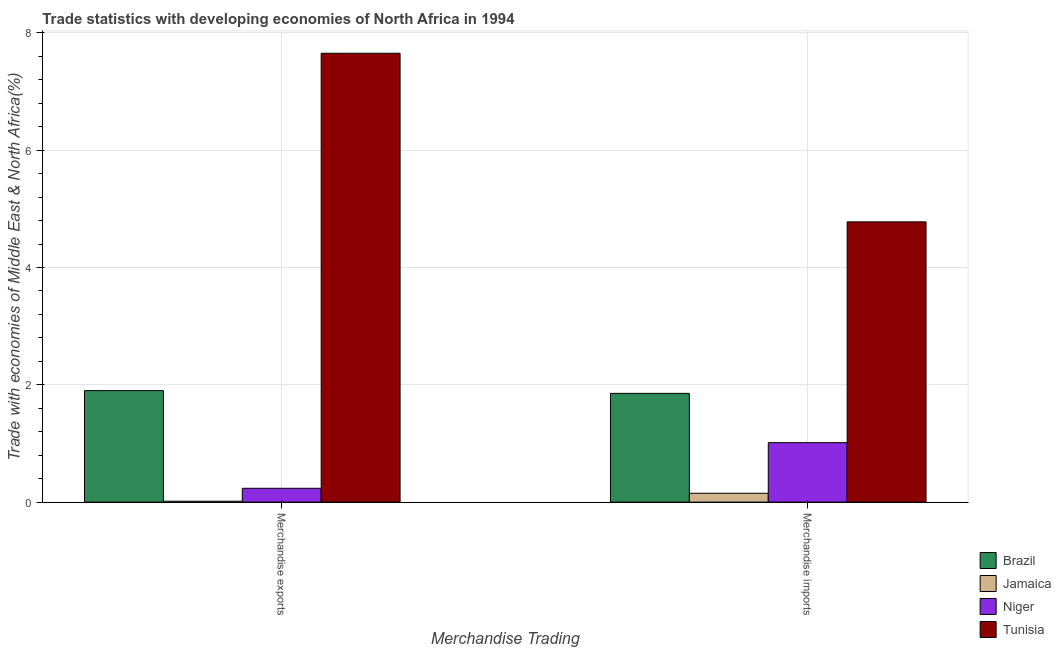How many different coloured bars are there?
Keep it short and to the point. 4. Are the number of bars per tick equal to the number of legend labels?
Offer a very short reply. Yes. How many bars are there on the 2nd tick from the left?
Provide a succinct answer. 4. What is the label of the 1st group of bars from the left?
Your answer should be very brief. Merchandise exports. What is the merchandise exports in Brazil?
Ensure brevity in your answer.  1.9. Across all countries, what is the maximum merchandise imports?
Give a very brief answer. 4.78. Across all countries, what is the minimum merchandise imports?
Your response must be concise. 0.15. In which country was the merchandise exports maximum?
Your response must be concise. Tunisia. In which country was the merchandise imports minimum?
Your answer should be compact. Jamaica. What is the total merchandise imports in the graph?
Your response must be concise. 7.8. What is the difference between the merchandise exports in Jamaica and that in Niger?
Make the answer very short. -0.22. What is the difference between the merchandise exports in Niger and the merchandise imports in Tunisia?
Give a very brief answer. -4.54. What is the average merchandise imports per country?
Give a very brief answer. 1.95. What is the difference between the merchandise imports and merchandise exports in Jamaica?
Make the answer very short. 0.14. In how many countries, is the merchandise exports greater than 5.6 %?
Keep it short and to the point. 1. What is the ratio of the merchandise exports in Tunisia to that in Jamaica?
Your answer should be compact. 501.51. Is the merchandise exports in Niger less than that in Brazil?
Your response must be concise. Yes. In how many countries, is the merchandise imports greater than the average merchandise imports taken over all countries?
Your answer should be compact. 1. What does the 3rd bar from the right in Merchandise imports represents?
Make the answer very short. Jamaica. How many countries are there in the graph?
Give a very brief answer. 4. What is the difference between two consecutive major ticks on the Y-axis?
Provide a short and direct response. 2. Are the values on the major ticks of Y-axis written in scientific E-notation?
Your response must be concise. No. Does the graph contain any zero values?
Offer a very short reply. No. Does the graph contain grids?
Give a very brief answer. Yes. How many legend labels are there?
Your answer should be compact. 4. What is the title of the graph?
Your response must be concise. Trade statistics with developing economies of North Africa in 1994. What is the label or title of the X-axis?
Keep it short and to the point. Merchandise Trading. What is the label or title of the Y-axis?
Your answer should be very brief. Trade with economies of Middle East & North Africa(%). What is the Trade with economies of Middle East & North Africa(%) in Brazil in Merchandise exports?
Your response must be concise. 1.9. What is the Trade with economies of Middle East & North Africa(%) in Jamaica in Merchandise exports?
Provide a succinct answer. 0.02. What is the Trade with economies of Middle East & North Africa(%) of Niger in Merchandise exports?
Provide a succinct answer. 0.24. What is the Trade with economies of Middle East & North Africa(%) of Tunisia in Merchandise exports?
Your answer should be very brief. 7.65. What is the Trade with economies of Middle East & North Africa(%) of Brazil in Merchandise imports?
Offer a terse response. 1.85. What is the Trade with economies of Middle East & North Africa(%) in Jamaica in Merchandise imports?
Offer a very short reply. 0.15. What is the Trade with economies of Middle East & North Africa(%) of Niger in Merchandise imports?
Provide a succinct answer. 1.01. What is the Trade with economies of Middle East & North Africa(%) in Tunisia in Merchandise imports?
Provide a succinct answer. 4.78. Across all Merchandise Trading, what is the maximum Trade with economies of Middle East & North Africa(%) in Brazil?
Your answer should be very brief. 1.9. Across all Merchandise Trading, what is the maximum Trade with economies of Middle East & North Africa(%) of Jamaica?
Your answer should be compact. 0.15. Across all Merchandise Trading, what is the maximum Trade with economies of Middle East & North Africa(%) in Niger?
Ensure brevity in your answer.  1.01. Across all Merchandise Trading, what is the maximum Trade with economies of Middle East & North Africa(%) of Tunisia?
Your answer should be very brief. 7.65. Across all Merchandise Trading, what is the minimum Trade with economies of Middle East & North Africa(%) of Brazil?
Ensure brevity in your answer.  1.85. Across all Merchandise Trading, what is the minimum Trade with economies of Middle East & North Africa(%) of Jamaica?
Provide a succinct answer. 0.02. Across all Merchandise Trading, what is the minimum Trade with economies of Middle East & North Africa(%) in Niger?
Offer a terse response. 0.24. Across all Merchandise Trading, what is the minimum Trade with economies of Middle East & North Africa(%) in Tunisia?
Your response must be concise. 4.78. What is the total Trade with economies of Middle East & North Africa(%) of Brazil in the graph?
Keep it short and to the point. 3.76. What is the total Trade with economies of Middle East & North Africa(%) in Jamaica in the graph?
Offer a very short reply. 0.17. What is the total Trade with economies of Middle East & North Africa(%) of Niger in the graph?
Your answer should be compact. 1.25. What is the total Trade with economies of Middle East & North Africa(%) of Tunisia in the graph?
Ensure brevity in your answer.  12.43. What is the difference between the Trade with economies of Middle East & North Africa(%) of Brazil in Merchandise exports and that in Merchandise imports?
Your answer should be very brief. 0.05. What is the difference between the Trade with economies of Middle East & North Africa(%) in Jamaica in Merchandise exports and that in Merchandise imports?
Make the answer very short. -0.14. What is the difference between the Trade with economies of Middle East & North Africa(%) of Niger in Merchandise exports and that in Merchandise imports?
Make the answer very short. -0.78. What is the difference between the Trade with economies of Middle East & North Africa(%) of Tunisia in Merchandise exports and that in Merchandise imports?
Give a very brief answer. 2.87. What is the difference between the Trade with economies of Middle East & North Africa(%) in Brazil in Merchandise exports and the Trade with economies of Middle East & North Africa(%) in Jamaica in Merchandise imports?
Provide a short and direct response. 1.75. What is the difference between the Trade with economies of Middle East & North Africa(%) of Brazil in Merchandise exports and the Trade with economies of Middle East & North Africa(%) of Niger in Merchandise imports?
Your response must be concise. 0.89. What is the difference between the Trade with economies of Middle East & North Africa(%) of Brazil in Merchandise exports and the Trade with economies of Middle East & North Africa(%) of Tunisia in Merchandise imports?
Provide a short and direct response. -2.88. What is the difference between the Trade with economies of Middle East & North Africa(%) in Jamaica in Merchandise exports and the Trade with economies of Middle East & North Africa(%) in Niger in Merchandise imports?
Make the answer very short. -1. What is the difference between the Trade with economies of Middle East & North Africa(%) of Jamaica in Merchandise exports and the Trade with economies of Middle East & North Africa(%) of Tunisia in Merchandise imports?
Offer a very short reply. -4.76. What is the difference between the Trade with economies of Middle East & North Africa(%) of Niger in Merchandise exports and the Trade with economies of Middle East & North Africa(%) of Tunisia in Merchandise imports?
Make the answer very short. -4.54. What is the average Trade with economies of Middle East & North Africa(%) in Brazil per Merchandise Trading?
Ensure brevity in your answer.  1.88. What is the average Trade with economies of Middle East & North Africa(%) of Jamaica per Merchandise Trading?
Make the answer very short. 0.08. What is the average Trade with economies of Middle East & North Africa(%) in Niger per Merchandise Trading?
Offer a terse response. 0.62. What is the average Trade with economies of Middle East & North Africa(%) of Tunisia per Merchandise Trading?
Keep it short and to the point. 6.22. What is the difference between the Trade with economies of Middle East & North Africa(%) in Brazil and Trade with economies of Middle East & North Africa(%) in Jamaica in Merchandise exports?
Your answer should be very brief. 1.89. What is the difference between the Trade with economies of Middle East & North Africa(%) of Brazil and Trade with economies of Middle East & North Africa(%) of Niger in Merchandise exports?
Offer a terse response. 1.67. What is the difference between the Trade with economies of Middle East & North Africa(%) in Brazil and Trade with economies of Middle East & North Africa(%) in Tunisia in Merchandise exports?
Make the answer very short. -5.75. What is the difference between the Trade with economies of Middle East & North Africa(%) in Jamaica and Trade with economies of Middle East & North Africa(%) in Niger in Merchandise exports?
Your response must be concise. -0.22. What is the difference between the Trade with economies of Middle East & North Africa(%) of Jamaica and Trade with economies of Middle East & North Africa(%) of Tunisia in Merchandise exports?
Your response must be concise. -7.64. What is the difference between the Trade with economies of Middle East & North Africa(%) of Niger and Trade with economies of Middle East & North Africa(%) of Tunisia in Merchandise exports?
Offer a very short reply. -7.42. What is the difference between the Trade with economies of Middle East & North Africa(%) in Brazil and Trade with economies of Middle East & North Africa(%) in Jamaica in Merchandise imports?
Your response must be concise. 1.7. What is the difference between the Trade with economies of Middle East & North Africa(%) in Brazil and Trade with economies of Middle East & North Africa(%) in Niger in Merchandise imports?
Offer a very short reply. 0.84. What is the difference between the Trade with economies of Middle East & North Africa(%) of Brazil and Trade with economies of Middle East & North Africa(%) of Tunisia in Merchandise imports?
Your response must be concise. -2.92. What is the difference between the Trade with economies of Middle East & North Africa(%) of Jamaica and Trade with economies of Middle East & North Africa(%) of Niger in Merchandise imports?
Offer a terse response. -0.86. What is the difference between the Trade with economies of Middle East & North Africa(%) of Jamaica and Trade with economies of Middle East & North Africa(%) of Tunisia in Merchandise imports?
Offer a very short reply. -4.63. What is the difference between the Trade with economies of Middle East & North Africa(%) in Niger and Trade with economies of Middle East & North Africa(%) in Tunisia in Merchandise imports?
Your answer should be very brief. -3.76. What is the ratio of the Trade with economies of Middle East & North Africa(%) in Brazil in Merchandise exports to that in Merchandise imports?
Offer a terse response. 1.03. What is the ratio of the Trade with economies of Middle East & North Africa(%) in Jamaica in Merchandise exports to that in Merchandise imports?
Keep it short and to the point. 0.1. What is the ratio of the Trade with economies of Middle East & North Africa(%) in Niger in Merchandise exports to that in Merchandise imports?
Offer a terse response. 0.23. What is the ratio of the Trade with economies of Middle East & North Africa(%) of Tunisia in Merchandise exports to that in Merchandise imports?
Give a very brief answer. 1.6. What is the difference between the highest and the second highest Trade with economies of Middle East & North Africa(%) of Brazil?
Offer a very short reply. 0.05. What is the difference between the highest and the second highest Trade with economies of Middle East & North Africa(%) of Jamaica?
Give a very brief answer. 0.14. What is the difference between the highest and the second highest Trade with economies of Middle East & North Africa(%) of Niger?
Offer a terse response. 0.78. What is the difference between the highest and the second highest Trade with economies of Middle East & North Africa(%) of Tunisia?
Provide a short and direct response. 2.87. What is the difference between the highest and the lowest Trade with economies of Middle East & North Africa(%) of Brazil?
Make the answer very short. 0.05. What is the difference between the highest and the lowest Trade with economies of Middle East & North Africa(%) in Jamaica?
Ensure brevity in your answer.  0.14. What is the difference between the highest and the lowest Trade with economies of Middle East & North Africa(%) of Niger?
Give a very brief answer. 0.78. What is the difference between the highest and the lowest Trade with economies of Middle East & North Africa(%) of Tunisia?
Provide a succinct answer. 2.87. 